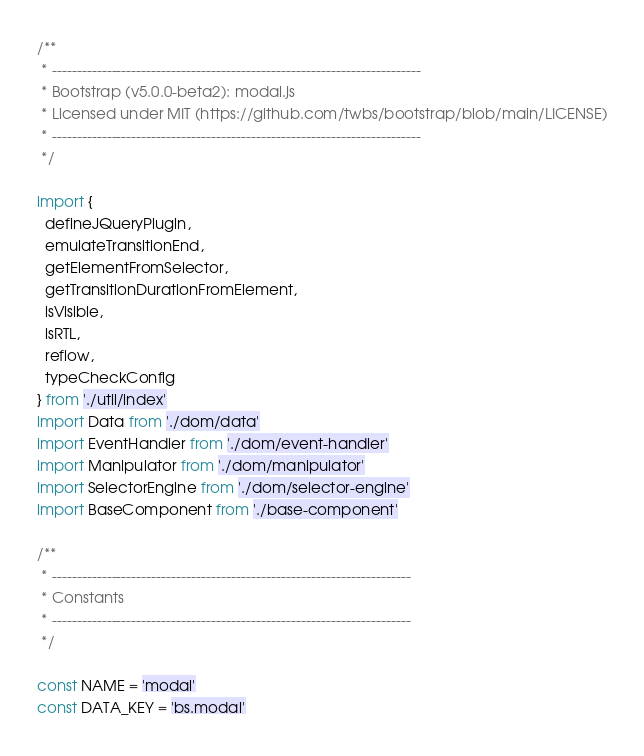Convert code to text. <code><loc_0><loc_0><loc_500><loc_500><_JavaScript_>/**
 * --------------------------------------------------------------------------
 * Bootstrap (v5.0.0-beta2): modal.js
 * Licensed under MIT (https://github.com/twbs/bootstrap/blob/main/LICENSE)
 * --------------------------------------------------------------------------
 */

import {
  defineJQueryPlugin,
  emulateTransitionEnd,
  getElementFromSelector,
  getTransitionDurationFromElement,
  isVisible,
  isRTL,
  reflow,
  typeCheckConfig
} from './util/index'
import Data from './dom/data'
import EventHandler from './dom/event-handler'
import Manipulator from './dom/manipulator'
import SelectorEngine from './dom/selector-engine'
import BaseComponent from './base-component'

/**
 * ------------------------------------------------------------------------
 * Constants
 * ------------------------------------------------------------------------
 */

const NAME = 'modal'
const DATA_KEY = 'bs.modal'</code> 